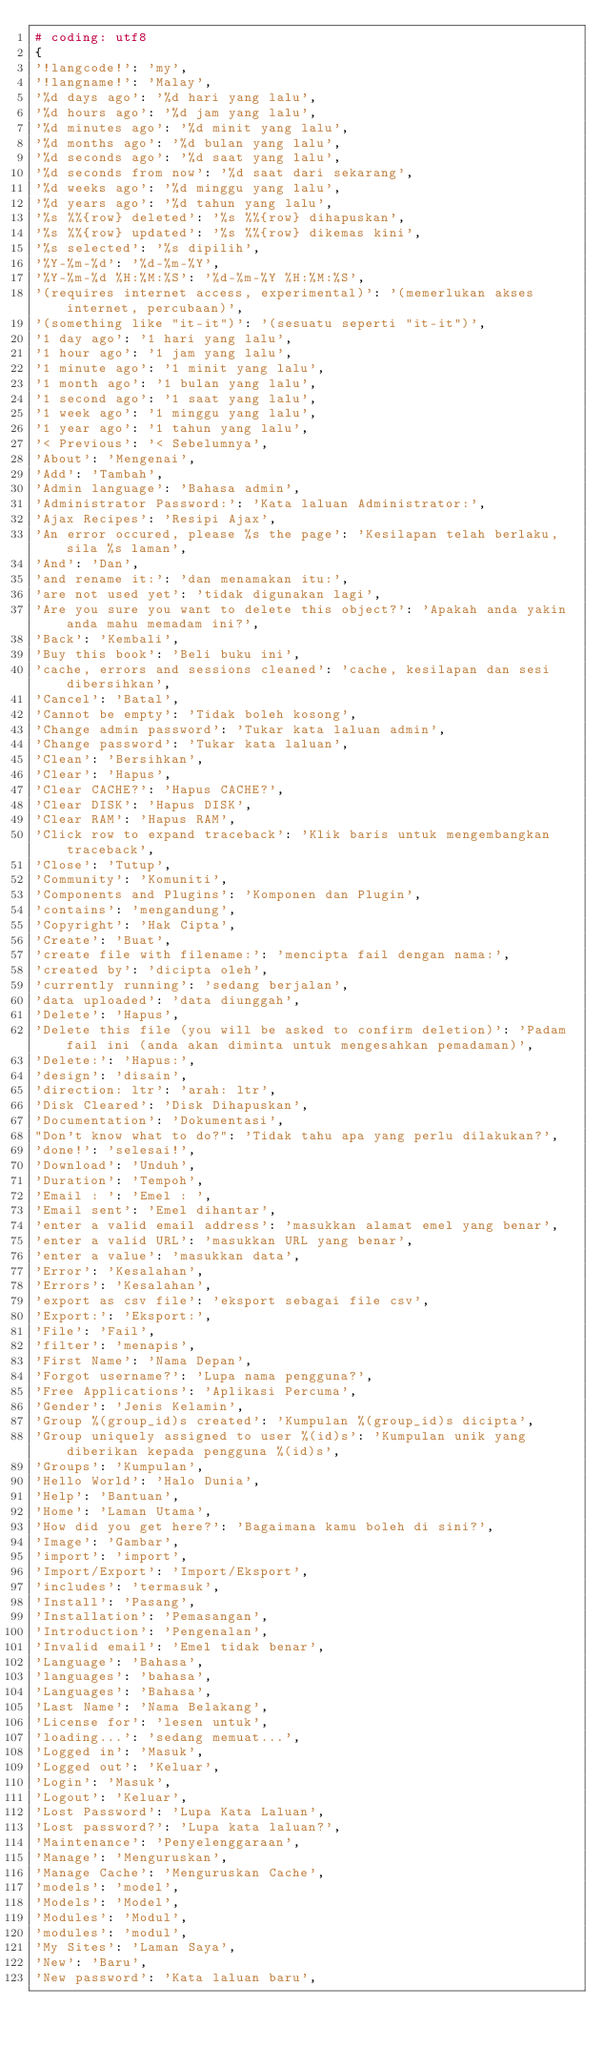<code> <loc_0><loc_0><loc_500><loc_500><_Python_># coding: utf8
{
'!langcode!': 'my',
'!langname!': 'Malay',
'%d days ago': '%d hari yang lalu',
'%d hours ago': '%d jam yang lalu',
'%d minutes ago': '%d minit yang lalu',
'%d months ago': '%d bulan yang lalu',
'%d seconds ago': '%d saat yang lalu',
'%d seconds from now': '%d saat dari sekarang',
'%d weeks ago': '%d minggu yang lalu',
'%d years ago': '%d tahun yang lalu',
'%s %%{row} deleted': '%s %%{row} dihapuskan',
'%s %%{row} updated': '%s %%{row} dikemas kini',
'%s selected': '%s dipilih',
'%Y-%m-%d': '%d-%m-%Y',
'%Y-%m-%d %H:%M:%S': '%d-%m-%Y %H:%M:%S',
'(requires internet access, experimental)': '(memerlukan akses internet, percubaan)',
'(something like "it-it")': '(sesuatu seperti "it-it")',
'1 day ago': '1 hari yang lalu',
'1 hour ago': '1 jam yang lalu',
'1 minute ago': '1 minit yang lalu',
'1 month ago': '1 bulan yang lalu',
'1 second ago': '1 saat yang lalu',
'1 week ago': '1 minggu yang lalu',
'1 year ago': '1 tahun yang lalu',
'< Previous': '< Sebelumnya',
'About': 'Mengenai',
'Add': 'Tambah',
'Admin language': 'Bahasa admin',
'Administrator Password:': 'Kata laluan Administrator:',
'Ajax Recipes': 'Resipi Ajax',
'An error occured, please %s the page': 'Kesilapan telah berlaku, sila %s laman',
'And': 'Dan',
'and rename it:': 'dan menamakan itu:',
'are not used yet': 'tidak digunakan lagi',
'Are you sure you want to delete this object?': 'Apakah anda yakin anda mahu memadam ini?',
'Back': 'Kembali',
'Buy this book': 'Beli buku ini',
'cache, errors and sessions cleaned': 'cache, kesilapan dan sesi dibersihkan',
'Cancel': 'Batal',
'Cannot be empty': 'Tidak boleh kosong',
'Change admin password': 'Tukar kata laluan admin',
'Change password': 'Tukar kata laluan',
'Clean': 'Bersihkan',
'Clear': 'Hapus',
'Clear CACHE?': 'Hapus CACHE?',
'Clear DISK': 'Hapus DISK',
'Clear RAM': 'Hapus RAM',
'Click row to expand traceback': 'Klik baris untuk mengembangkan traceback',
'Close': 'Tutup',
'Community': 'Komuniti',
'Components and Plugins': 'Komponen dan Plugin',
'contains': 'mengandung',
'Copyright': 'Hak Cipta',
'Create': 'Buat',
'create file with filename:': 'mencipta fail dengan nama:',
'created by': 'dicipta oleh',
'currently running': 'sedang berjalan',
'data uploaded': 'data diunggah',
'Delete': 'Hapus',
'Delete this file (you will be asked to confirm deletion)': 'Padam fail ini (anda akan diminta untuk mengesahkan pemadaman)',
'Delete:': 'Hapus:',
'design': 'disain',
'direction: ltr': 'arah: ltr',
'Disk Cleared': 'Disk Dihapuskan',
'Documentation': 'Dokumentasi',
"Don't know what to do?": 'Tidak tahu apa yang perlu dilakukan?',
'done!': 'selesai!',
'Download': 'Unduh',
'Duration': 'Tempoh',
'Email : ': 'Emel : ',
'Email sent': 'Emel dihantar',
'enter a valid email address': 'masukkan alamat emel yang benar',
'enter a valid URL': 'masukkan URL yang benar',
'enter a value': 'masukkan data',
'Error': 'Kesalahan',
'Errors': 'Kesalahan',
'export as csv file': 'eksport sebagai file csv',
'Export:': 'Eksport:',
'File': 'Fail',
'filter': 'menapis',
'First Name': 'Nama Depan',
'Forgot username?': 'Lupa nama pengguna?',
'Free Applications': 'Aplikasi Percuma',
'Gender': 'Jenis Kelamin',
'Group %(group_id)s created': 'Kumpulan %(group_id)s dicipta',
'Group uniquely assigned to user %(id)s': 'Kumpulan unik yang diberikan kepada pengguna %(id)s',
'Groups': 'Kumpulan',
'Hello World': 'Halo Dunia',
'Help': 'Bantuan',
'Home': 'Laman Utama',
'How did you get here?': 'Bagaimana kamu boleh di sini?',
'Image': 'Gambar',
'import': 'import',
'Import/Export': 'Import/Eksport',
'includes': 'termasuk',
'Install': 'Pasang',
'Installation': 'Pemasangan',
'Introduction': 'Pengenalan',
'Invalid email': 'Emel tidak benar',
'Language': 'Bahasa',
'languages': 'bahasa',
'Languages': 'Bahasa',
'Last Name': 'Nama Belakang',
'License for': 'lesen untuk',
'loading...': 'sedang memuat...',
'Logged in': 'Masuk',
'Logged out': 'Keluar',
'Login': 'Masuk',
'Logout': 'Keluar',
'Lost Password': 'Lupa Kata Laluan',
'Lost password?': 'Lupa kata laluan?',
'Maintenance': 'Penyelenggaraan',
'Manage': 'Menguruskan',
'Manage Cache': 'Menguruskan Cache',
'models': 'model',
'Models': 'Model',
'Modules': 'Modul',
'modules': 'modul',
'My Sites': 'Laman Saya',
'New': 'Baru',
'New password': 'Kata laluan baru',</code> 